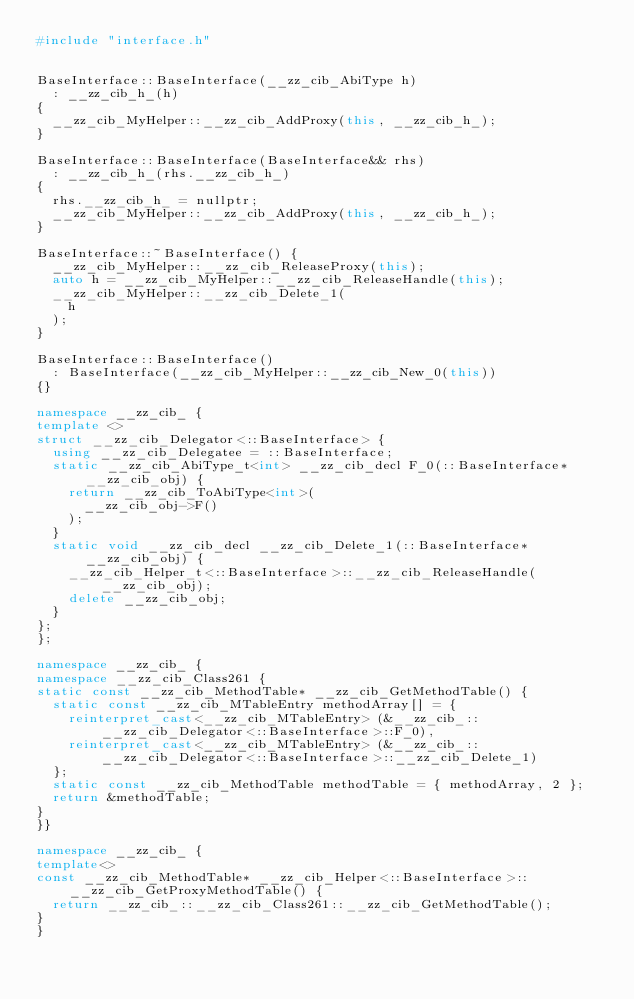<code> <loc_0><loc_0><loc_500><loc_500><_C++_>#include "interface.h"


BaseInterface::BaseInterface(__zz_cib_AbiType h)
  : __zz_cib_h_(h)
{
  __zz_cib_MyHelper::__zz_cib_AddProxy(this, __zz_cib_h_);
}

BaseInterface::BaseInterface(BaseInterface&& rhs)
  : __zz_cib_h_(rhs.__zz_cib_h_)
{
  rhs.__zz_cib_h_ = nullptr;
  __zz_cib_MyHelper::__zz_cib_AddProxy(this, __zz_cib_h_);
}

BaseInterface::~BaseInterface() {
  __zz_cib_MyHelper::__zz_cib_ReleaseProxy(this);
  auto h = __zz_cib_MyHelper::__zz_cib_ReleaseHandle(this);
  __zz_cib_MyHelper::__zz_cib_Delete_1(
    h
  );
}

BaseInterface::BaseInterface()
  : BaseInterface(__zz_cib_MyHelper::__zz_cib_New_0(this))
{}

namespace __zz_cib_ {
template <>
struct __zz_cib_Delegator<::BaseInterface> {
  using __zz_cib_Delegatee = ::BaseInterface;
  static __zz_cib_AbiType_t<int> __zz_cib_decl F_0(::BaseInterface* __zz_cib_obj) {
    return __zz_cib_ToAbiType<int>(
      __zz_cib_obj->F()
    );
  }
  static void __zz_cib_decl __zz_cib_Delete_1(::BaseInterface* __zz_cib_obj) {
    __zz_cib_Helper_t<::BaseInterface>::__zz_cib_ReleaseHandle(__zz_cib_obj);
    delete __zz_cib_obj;
  }
};
};

namespace __zz_cib_ {
namespace __zz_cib_Class261 {
static const __zz_cib_MethodTable* __zz_cib_GetMethodTable() {
  static const __zz_cib_MTableEntry methodArray[] = {
    reinterpret_cast<__zz_cib_MTableEntry> (&__zz_cib_::__zz_cib_Delegator<::BaseInterface>::F_0),
    reinterpret_cast<__zz_cib_MTableEntry> (&__zz_cib_::__zz_cib_Delegator<::BaseInterface>::__zz_cib_Delete_1)
  };
  static const __zz_cib_MethodTable methodTable = { methodArray, 2 };
  return &methodTable;
}
}}

namespace __zz_cib_ {
template<>
const __zz_cib_MethodTable* __zz_cib_Helper<::BaseInterface>::__zz_cib_GetProxyMethodTable() {
  return __zz_cib_::__zz_cib_Class261::__zz_cib_GetMethodTable();
}
}

</code> 